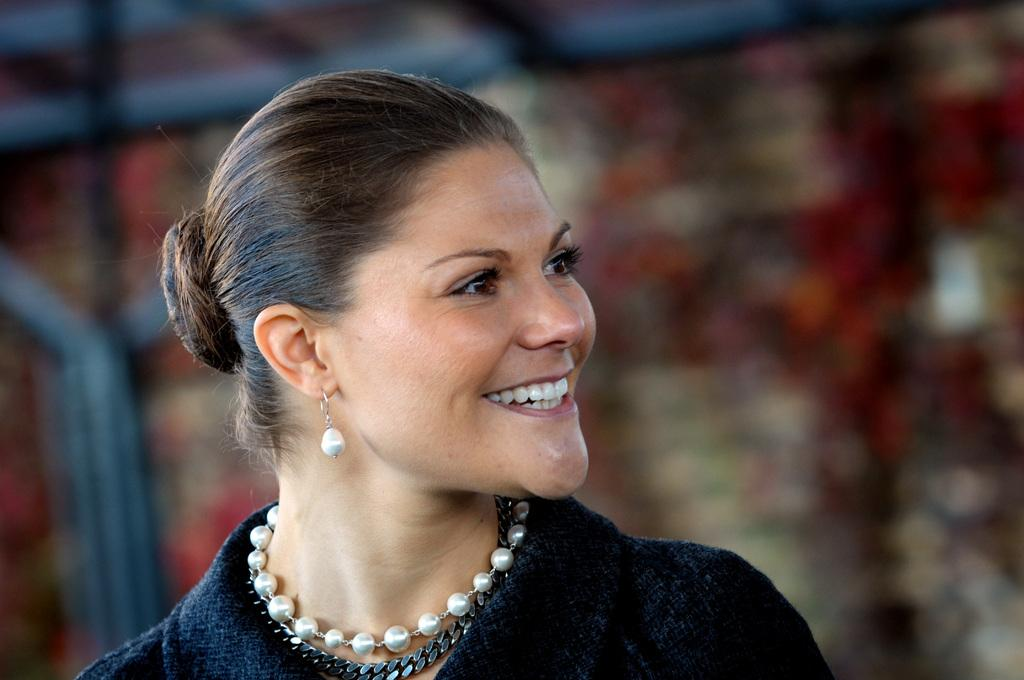Who is the main subject in the image? There is a woman in the image. Can you describe the background of the image? The background of the image is blurred. What type of coach is the woman driving in the image? There is no coach present in the image; it only features a woman and a blurred background. What type of quartz can be seen in the woman's hand in the image? There is no quartz present in the image, and the woman's hands are not visible. 